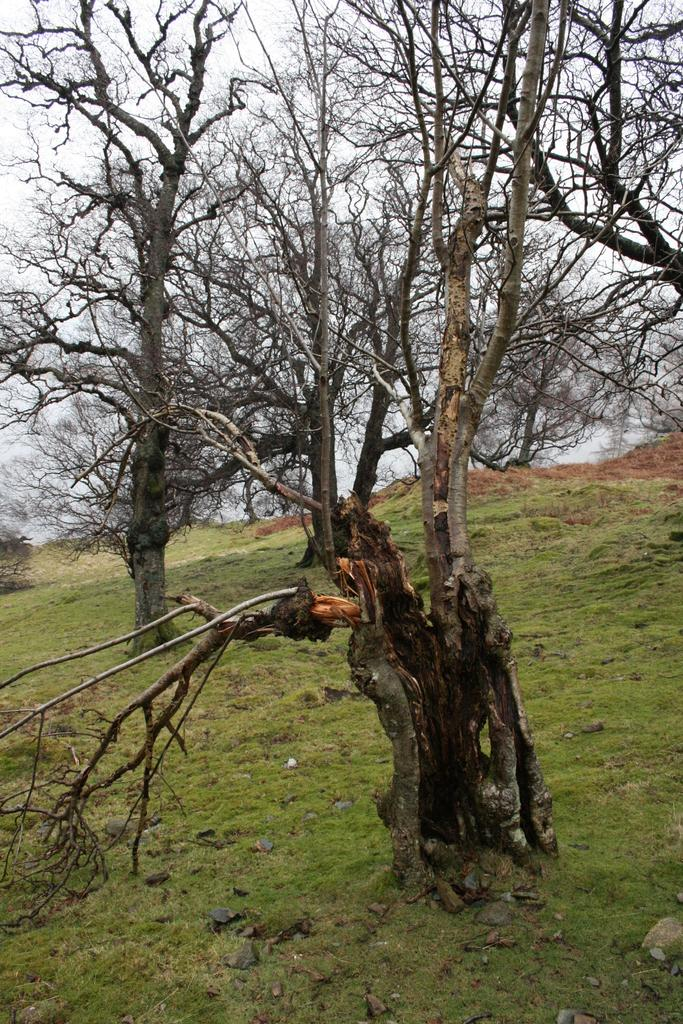What type of vegetation is present in the image without leaves? There are trees without leaves in the image. What type of ground cover can be seen in the image? There is grass on the floor in the image. What type of material is visible on the ground in the image? There are stones visible in the image. What is the condition of the sky in the image? The sky is clear in the image. Where is the shop located in the image? There is no shop present in the image. What type of sail can be seen in the image? There is no sail present in the image. 